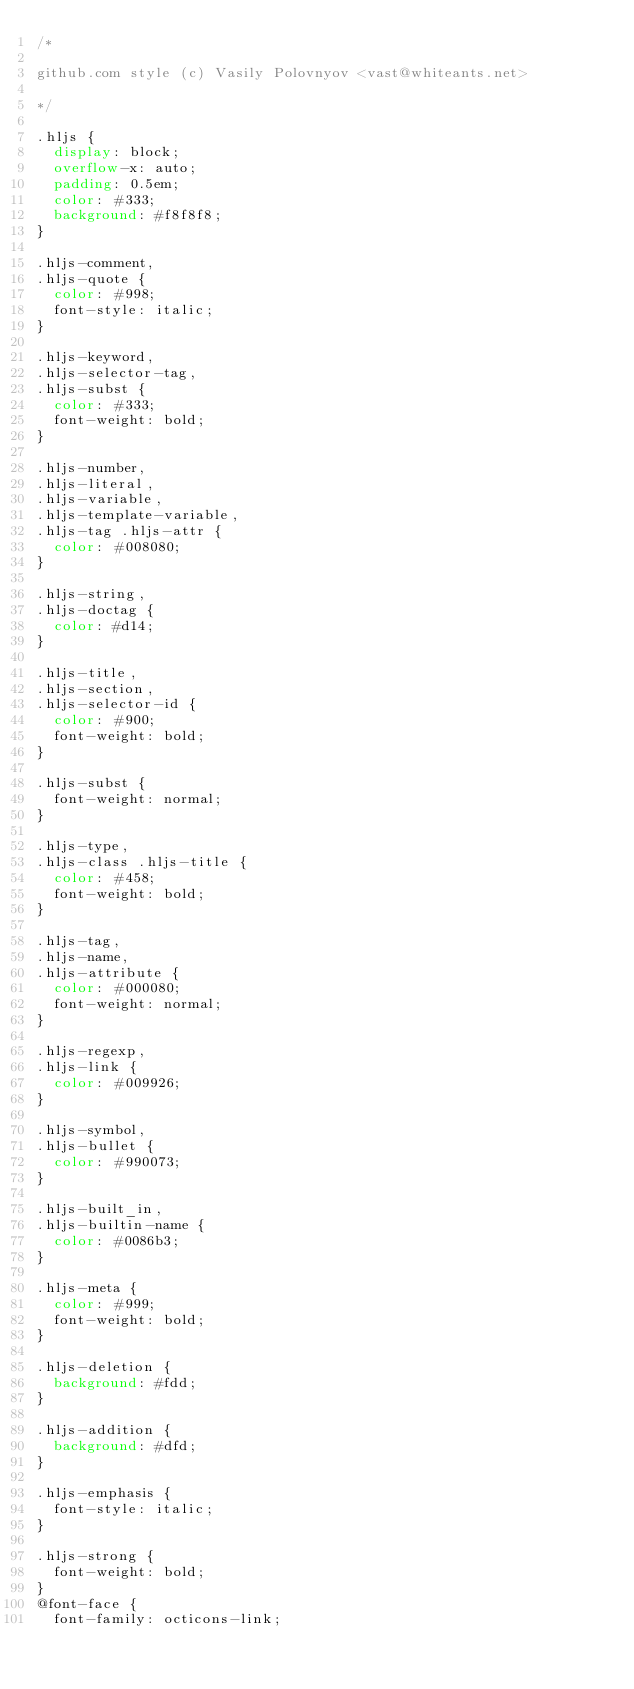Convert code to text. <code><loc_0><loc_0><loc_500><loc_500><_CSS_>/*

github.com style (c) Vasily Polovnyov <vast@whiteants.net>

*/

.hljs {
  display: block;
  overflow-x: auto;
  padding: 0.5em;
  color: #333;
  background: #f8f8f8;
}

.hljs-comment,
.hljs-quote {
  color: #998;
  font-style: italic;
}

.hljs-keyword,
.hljs-selector-tag,
.hljs-subst {
  color: #333;
  font-weight: bold;
}

.hljs-number,
.hljs-literal,
.hljs-variable,
.hljs-template-variable,
.hljs-tag .hljs-attr {
  color: #008080;
}

.hljs-string,
.hljs-doctag {
  color: #d14;
}

.hljs-title,
.hljs-section,
.hljs-selector-id {
  color: #900;
  font-weight: bold;
}

.hljs-subst {
  font-weight: normal;
}

.hljs-type,
.hljs-class .hljs-title {
  color: #458;
  font-weight: bold;
}

.hljs-tag,
.hljs-name,
.hljs-attribute {
  color: #000080;
  font-weight: normal;
}

.hljs-regexp,
.hljs-link {
  color: #009926;
}

.hljs-symbol,
.hljs-bullet {
  color: #990073;
}

.hljs-built_in,
.hljs-builtin-name {
  color: #0086b3;
}

.hljs-meta {
  color: #999;
  font-weight: bold;
}

.hljs-deletion {
  background: #fdd;
}

.hljs-addition {
  background: #dfd;
}

.hljs-emphasis {
  font-style: italic;
}

.hljs-strong {
  font-weight: bold;
}
@font-face {
  font-family: octicons-link;</code> 